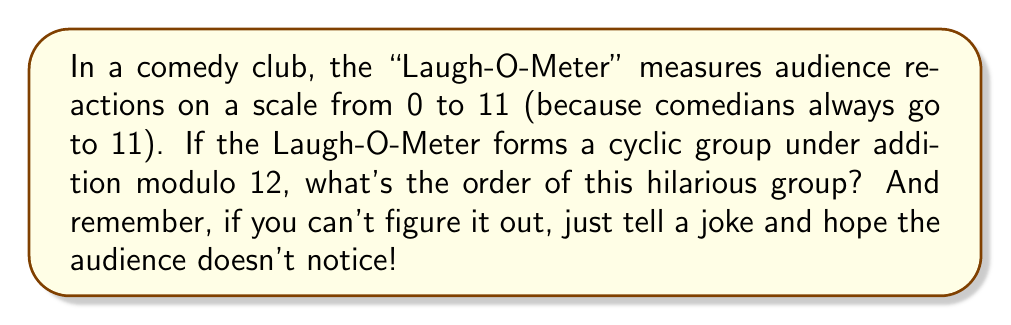Can you solve this math problem? Let's break this down with a bit of humor, shall we? 

1) First, we need to understand what we're dealing with. We have a cyclic group formed by the Laugh-O-Meter readings {0, 1, 2, ..., 11} under addition modulo 12. It's like a clock, but instead of hours, we're measuring laughs!

2) The order of a cyclic group is the smallest positive integer $n$ such that $ng = 0$ (identity element) for any generator $g$ of the group. In other words, how many times do we need to add the generator to itself before we get back to 0?

3) In this case, let's choose 1 as our generator. It's the smallest non-zero element, kind of like the first chuckle in a comedy set.

4) Now, let's start adding:
   $1 + 1 = 2$ (mod 12)
   $1 + 1 + 1 = 3$ (mod 12)
   ...
   $1 + 1 + ... + 1$ (11 times) $= 11$ (mod 12)
   $1 + 1 + ... + 1$ (12 times) $= 0$ (mod 12)

5) Aha! It took 12 additions of 1 to get back to 0. That's our answer!

6) Mathematically, we can express this as:

   $$12 \cdot 1 \equiv 0 \pmod{12}$$

7) This means that the order of the group is 12. It's like a full rotation of the Laugh-O-Meter, from polite chuckles all the way back to awkward silence!

Remember, in group theory, as in comedy, timing is everything. And in this case, our timing goes up to 12!
Answer: The order of the cyclic group is 12. 